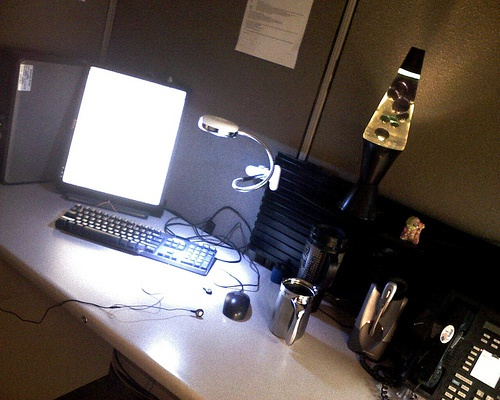Describe the objects in this image and their specific colors. I can see tv in black, white, and gray tones, keyboard in black, white, gray, lightblue, and navy tones, cup in black, gray, and white tones, cup in black, maroon, and tan tones, and mouse in black, navy, blue, and gray tones in this image. 